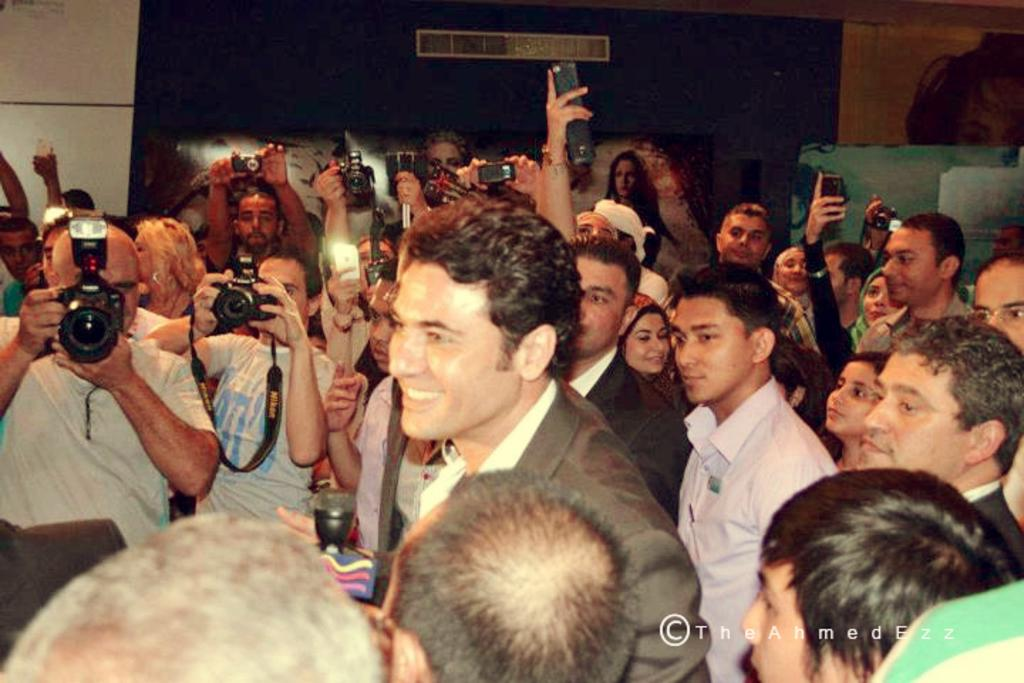How many people are present in the image? There are many people in the image. What are some people doing in the image? Some people are holding cameras. What can be seen in the background of the image? There is a wall in the background of the image. Is there any additional information or markings on the image? Yes, there is a watermark in the right corner of the image. What type of duck can be seen playing in the band in the image? There is no duck or band present in the image. What level of difficulty can be observed in the image? The image does not depict a level of difficulty; it is a photograph of people holding cameras. 